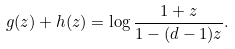Convert formula to latex. <formula><loc_0><loc_0><loc_500><loc_500>g ( z ) + h ( z ) = \log \frac { 1 + z } { 1 - ( d - 1 ) z } .</formula> 